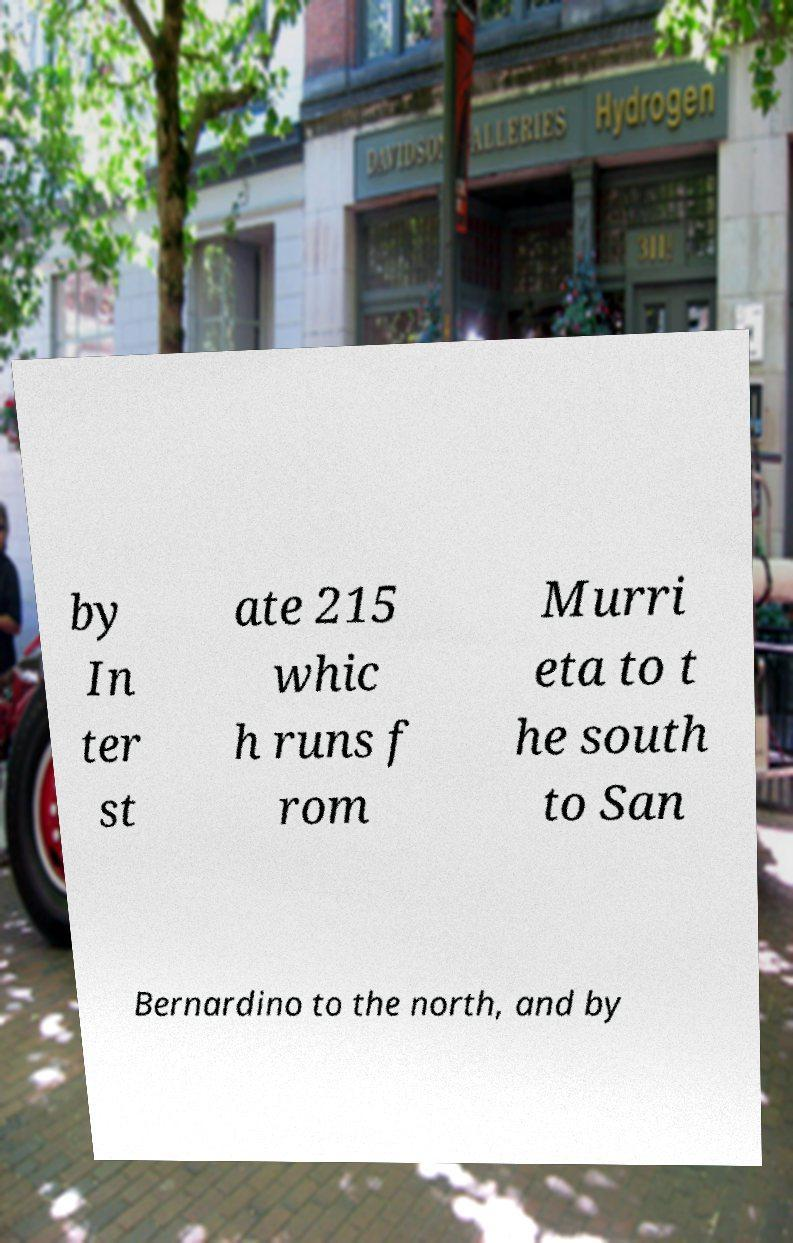What messages or text are displayed in this image? I need them in a readable, typed format. by In ter st ate 215 whic h runs f rom Murri eta to t he south to San Bernardino to the north, and by 